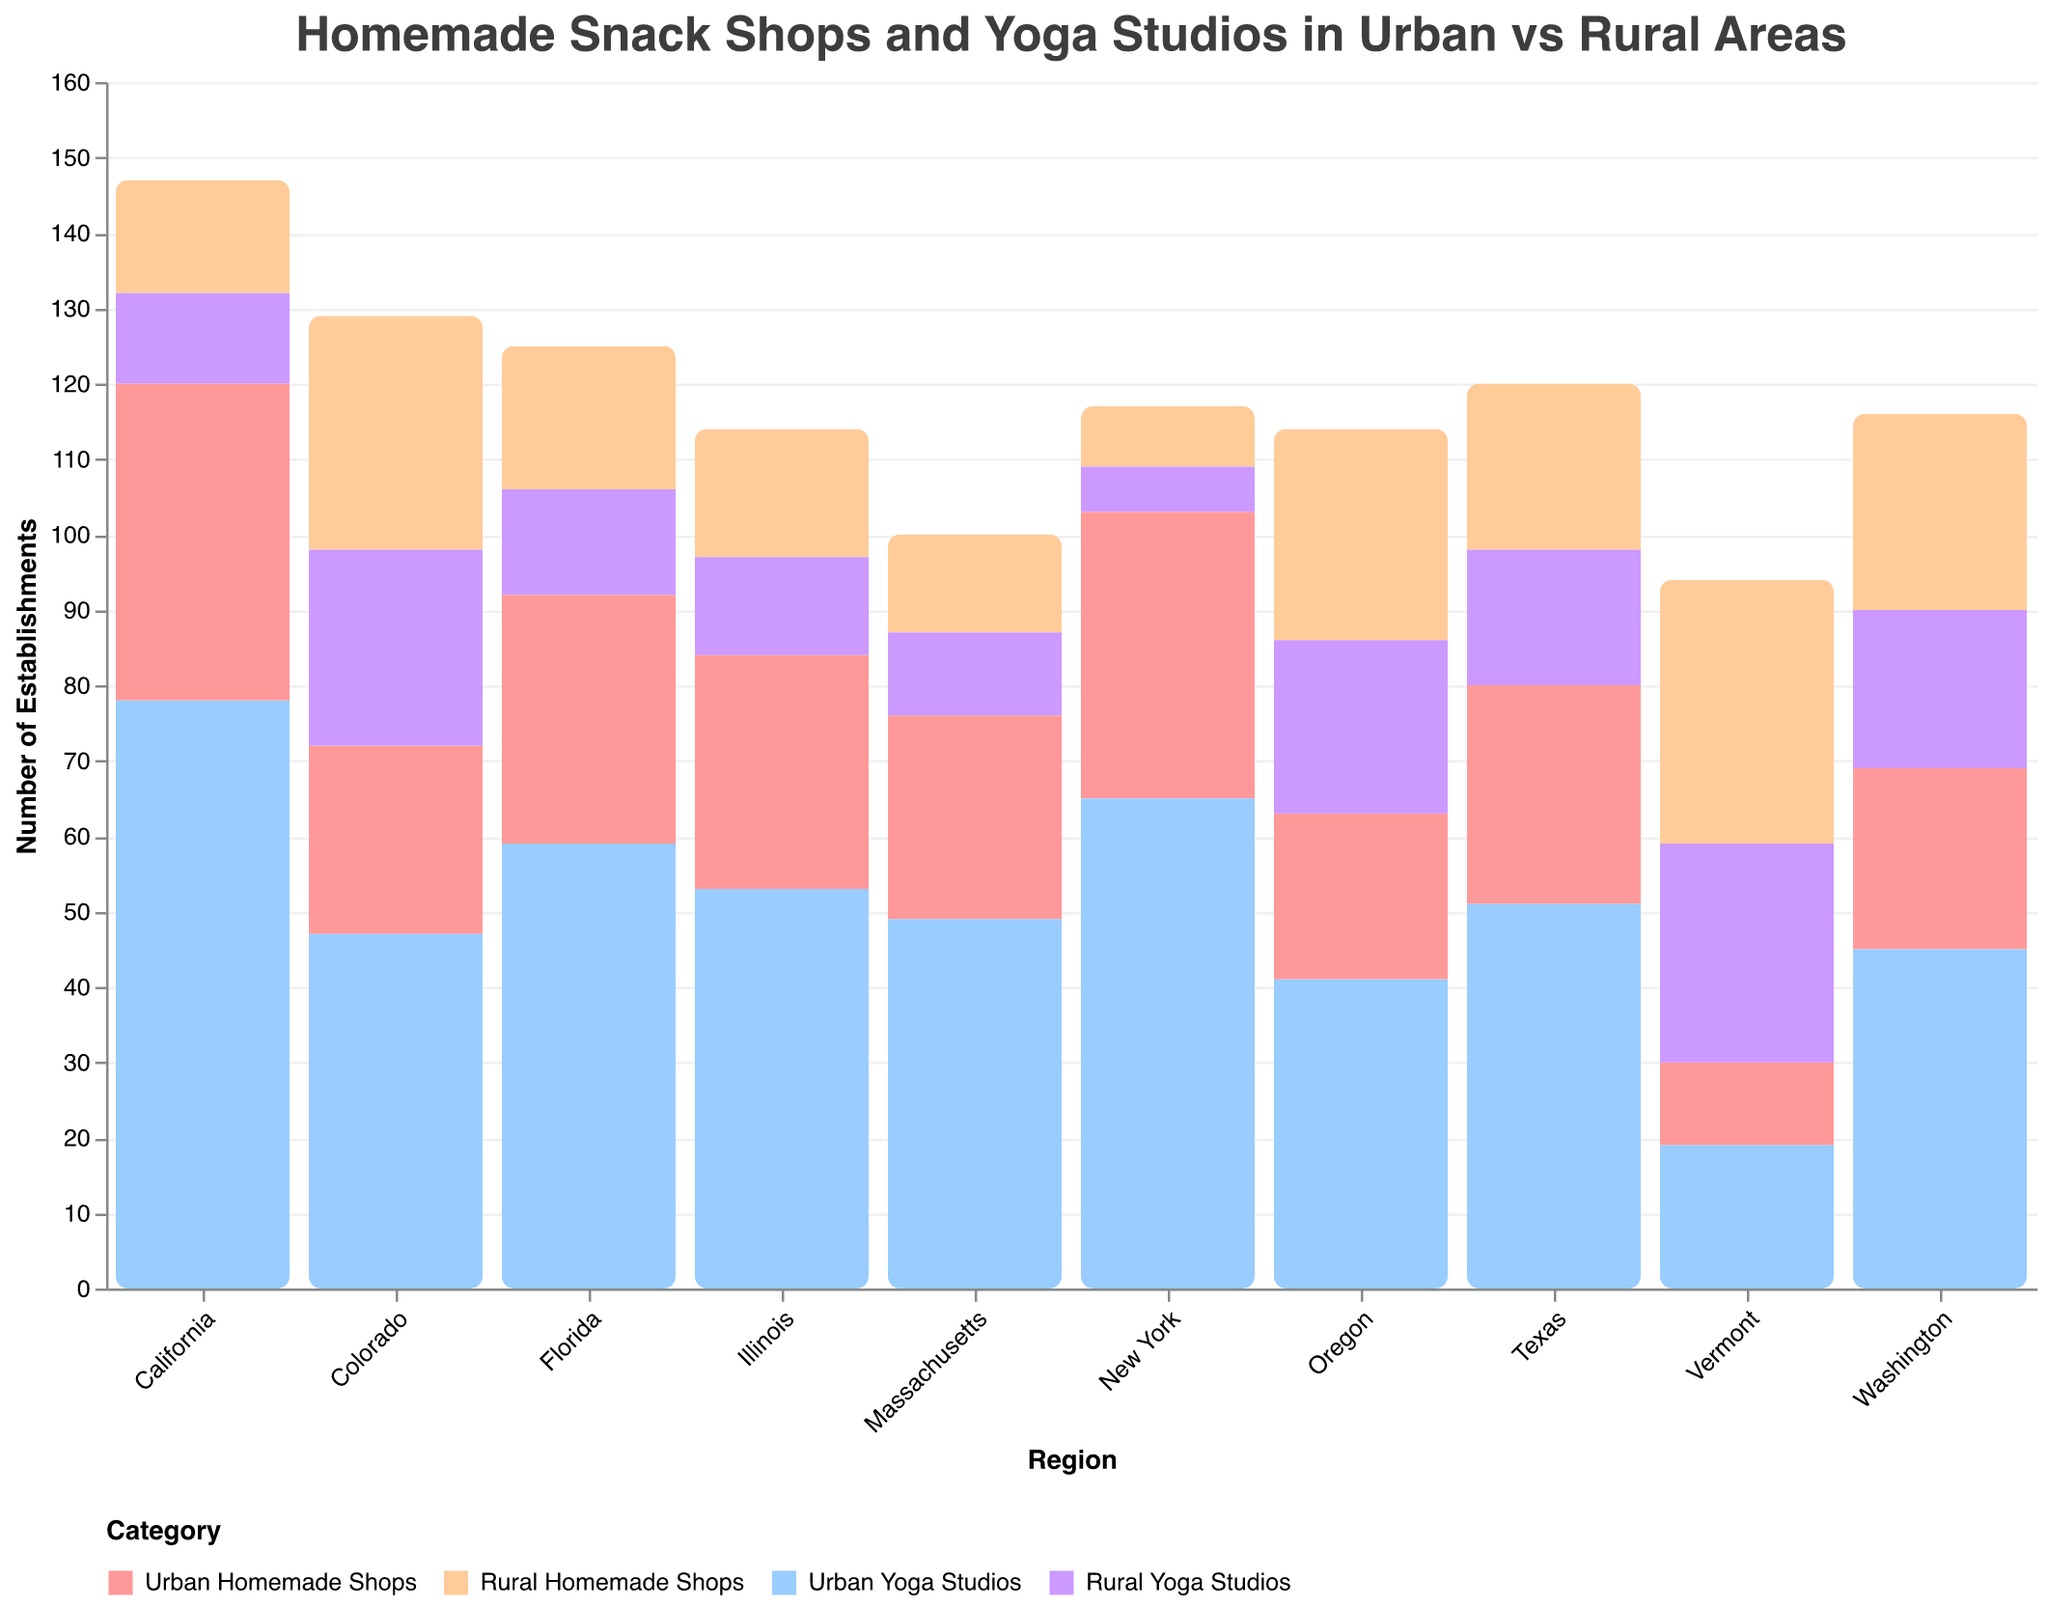What is the title of the chart? The title is located at the top of the chart and reads "Homemade Snack Shops and Yoga Studios in Urban vs Rural Areas"
Answer: Homemade Snack Shops and Yoga Studios in Urban vs Rural Areas Which region has the highest number of Urban Yoga Studios? By looking at the Urban Yoga Studios bar segments for each region, California has the highest number of Urban Yoga Studios.
Answer: California How many Rural Homemade Shops are there in Oregon? The color corresponding to Rural Homemade Shops in Oregon shows 28 bars.
Answer: 28 Compare the number of Urban Homemade Shops in California and Texas. Which one is greater? California has 42 Urban Homemade Shops, while Texas has 29. Therefore, California has more Urban Homemade Shops.
Answer: California What is the sum of Urban and Rural Yoga Studios in Florida? Florida has 59 Urban Yoga Studios and 14 Rural Yoga Studios. Adding these together gives 59 + 14 = 73.
Answer: 73 Which region has more Rural Yoga Studios, Vermont or Illinois? Vermont has 29 Rural Yoga Studios, while Illinois has 13. Therefore, Vermont has more.
Answer: Vermont Calculate the difference between Urban and Rural Homemade Shops in Colorado. Colorado has 25 Urban Homemade Shops and 31 Rural Homemade Shops. The difference is 31 - 25 = 6.
Answer: 6 Which region has the least number of Urban Homemade Shops? By comparing the Urban Homemade Shops across all regions, Vermont has the least with 11.
Answer: Vermont Is the number of Urban Yoga Studios in New York greater than the number of Urban Homemade Shops in the same region? New York has 65 Urban Yoga Studios and 38 Urban Homemade Shops. Since 65 > 38, there are more Urban Yoga Studios.
Answer: Yes How are Urban and Rural establishments distinguished in the chart? Urban and Rural establishments are distinguished by different colors and categories on the bars and legend. The Urban categories are presented in shades of red and blue, while the Rural categories are in shades of yellow and purple.
Answer: By different colors and categories 